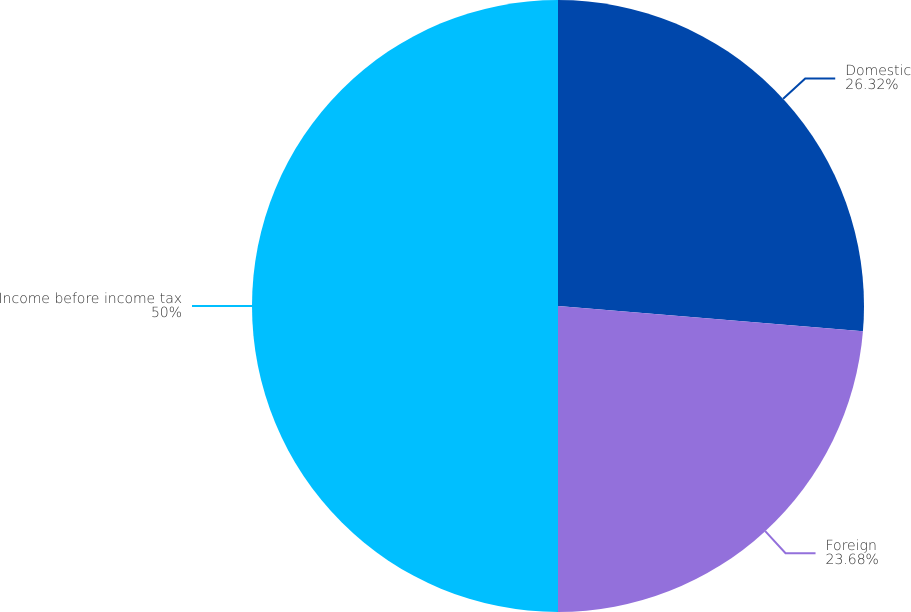Convert chart. <chart><loc_0><loc_0><loc_500><loc_500><pie_chart><fcel>Domestic<fcel>Foreign<fcel>Income before income tax<nl><fcel>26.32%<fcel>23.68%<fcel>50.0%<nl></chart> 